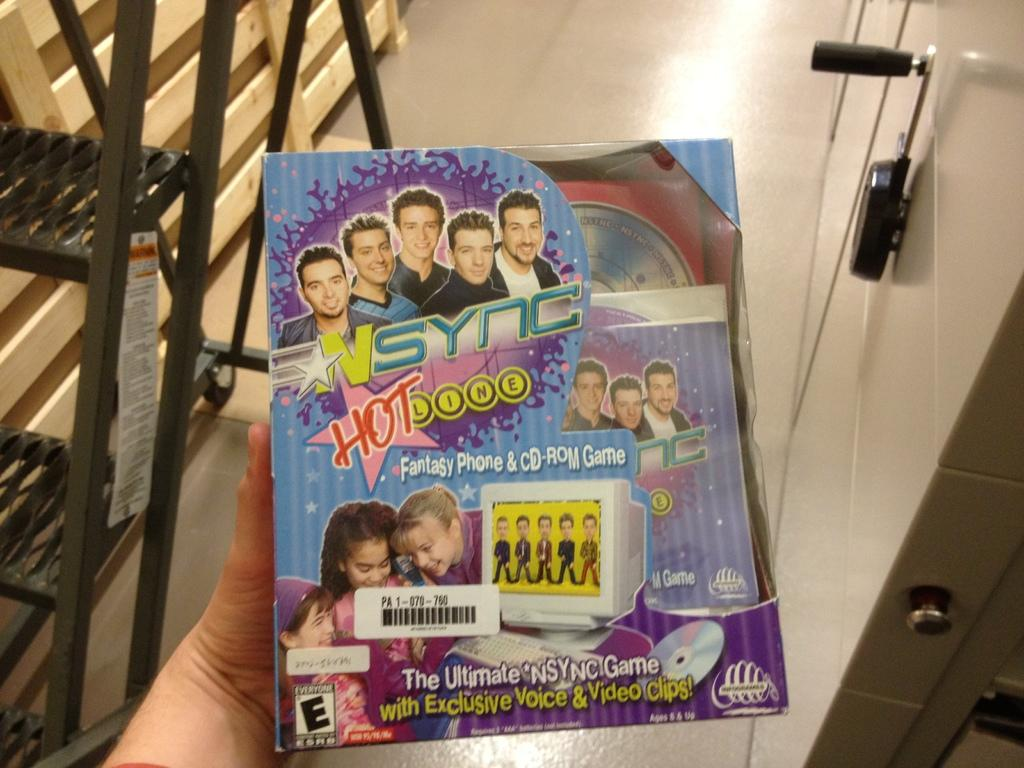What is the person in the image holding? The person is holding a box in the image. Can you describe the appearance of the box? The box is colorful. What other object can be seen in the image? There is a ladder in the image. What type of material is the wooden object made of? The wooden object is made of wood. What color is the object on the wall in the image? The object on the wall is black. What type of beast can be seen in the image? There is no beast present in the image. What message of peace can be read from the image? The image does not convey any specific message of peace, as it primarily focuses on the person holding a box and other objects in the scene. 